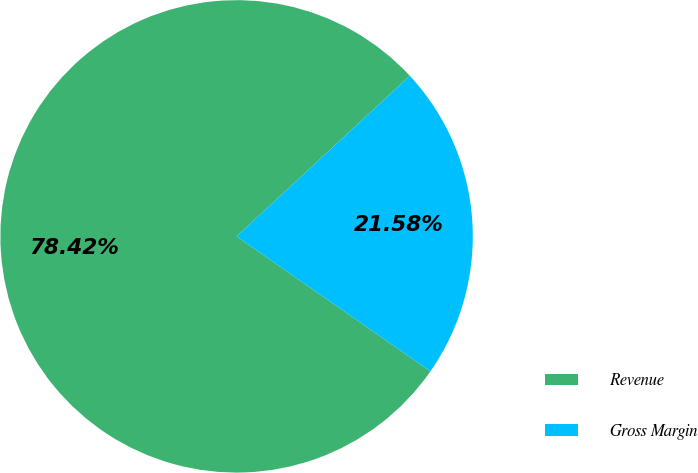Convert chart. <chart><loc_0><loc_0><loc_500><loc_500><pie_chart><fcel>Revenue<fcel>Gross Margin<nl><fcel>78.42%<fcel>21.58%<nl></chart> 